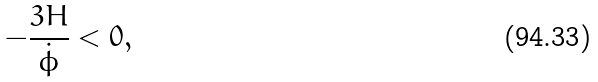Convert formula to latex. <formula><loc_0><loc_0><loc_500><loc_500>- \frac { 3 H } { \dot { \phi } } < 0 ,</formula> 